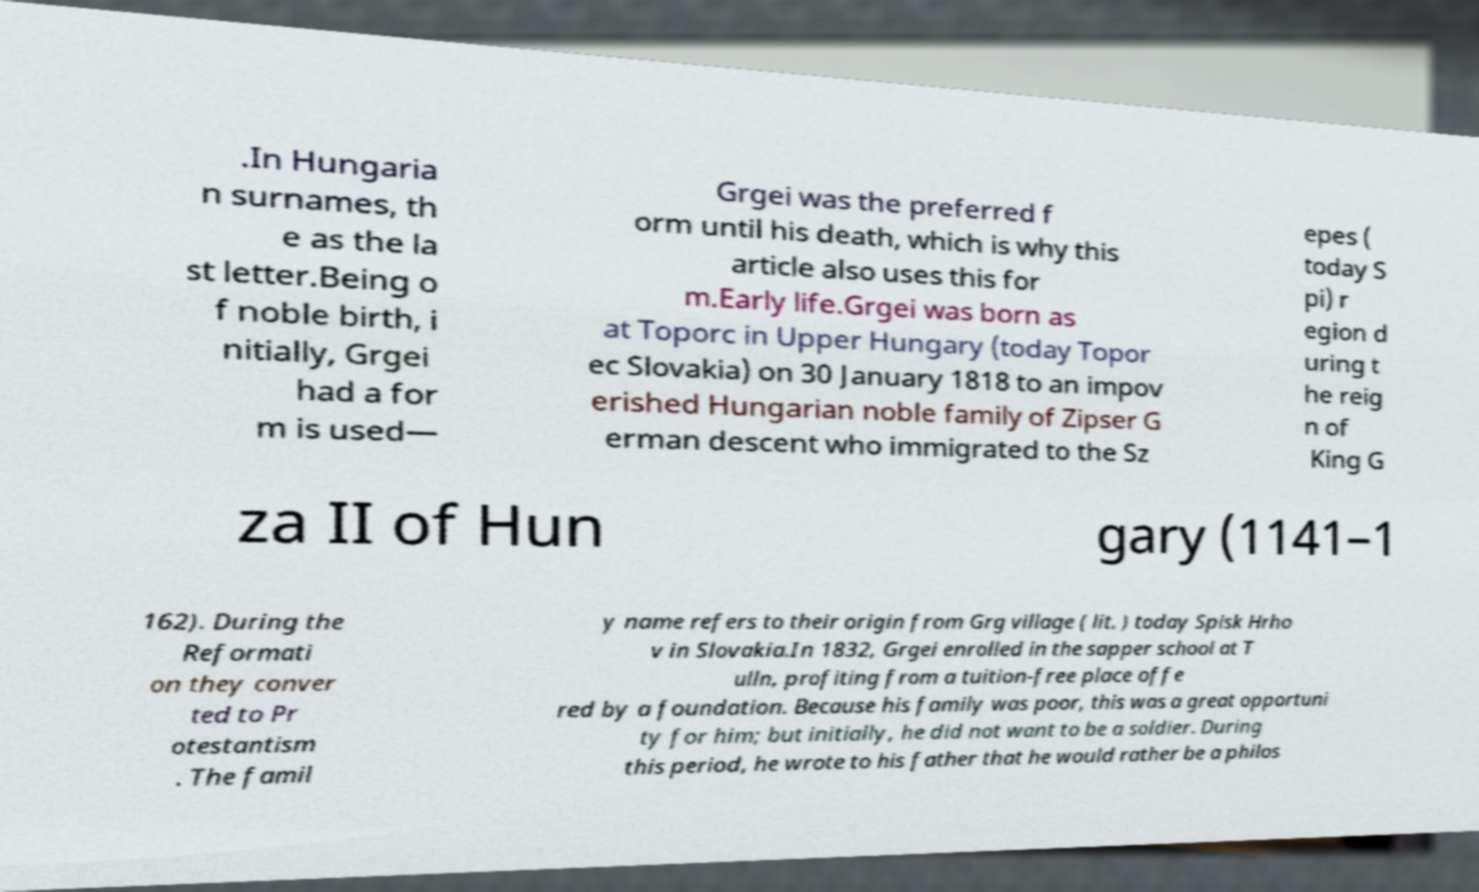For documentation purposes, I need the text within this image transcribed. Could you provide that? .In Hungaria n surnames, th e as the la st letter.Being o f noble birth, i nitially, Grgei had a for m is used— Grgei was the preferred f orm until his death, which is why this article also uses this for m.Early life.Grgei was born as at Toporc in Upper Hungary (today Topor ec Slovakia) on 30 January 1818 to an impov erished Hungarian noble family of Zipser G erman descent who immigrated to the Sz epes ( today S pi) r egion d uring t he reig n of King G za II of Hun gary (1141–1 162). During the Reformati on they conver ted to Pr otestantism . The famil y name refers to their origin from Grg village ( lit. ) today Spisk Hrho v in Slovakia.In 1832, Grgei enrolled in the sapper school at T ulln, profiting from a tuition-free place offe red by a foundation. Because his family was poor, this was a great opportuni ty for him; but initially, he did not want to be a soldier. During this period, he wrote to his father that he would rather be a philos 